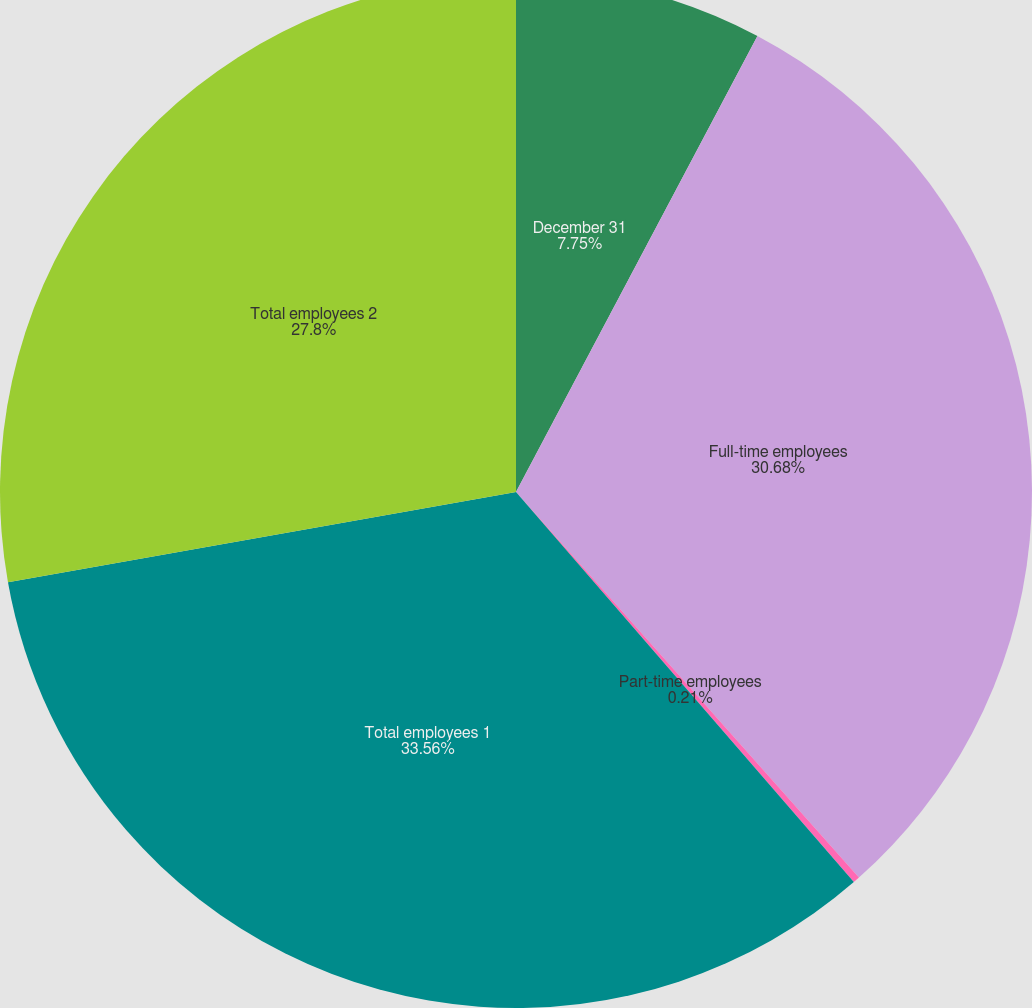<chart> <loc_0><loc_0><loc_500><loc_500><pie_chart><fcel>December 31<fcel>Full-time employees<fcel>Part-time employees<fcel>Total employees 1<fcel>Total employees 2<nl><fcel>7.75%<fcel>30.68%<fcel>0.21%<fcel>33.56%<fcel>27.8%<nl></chart> 